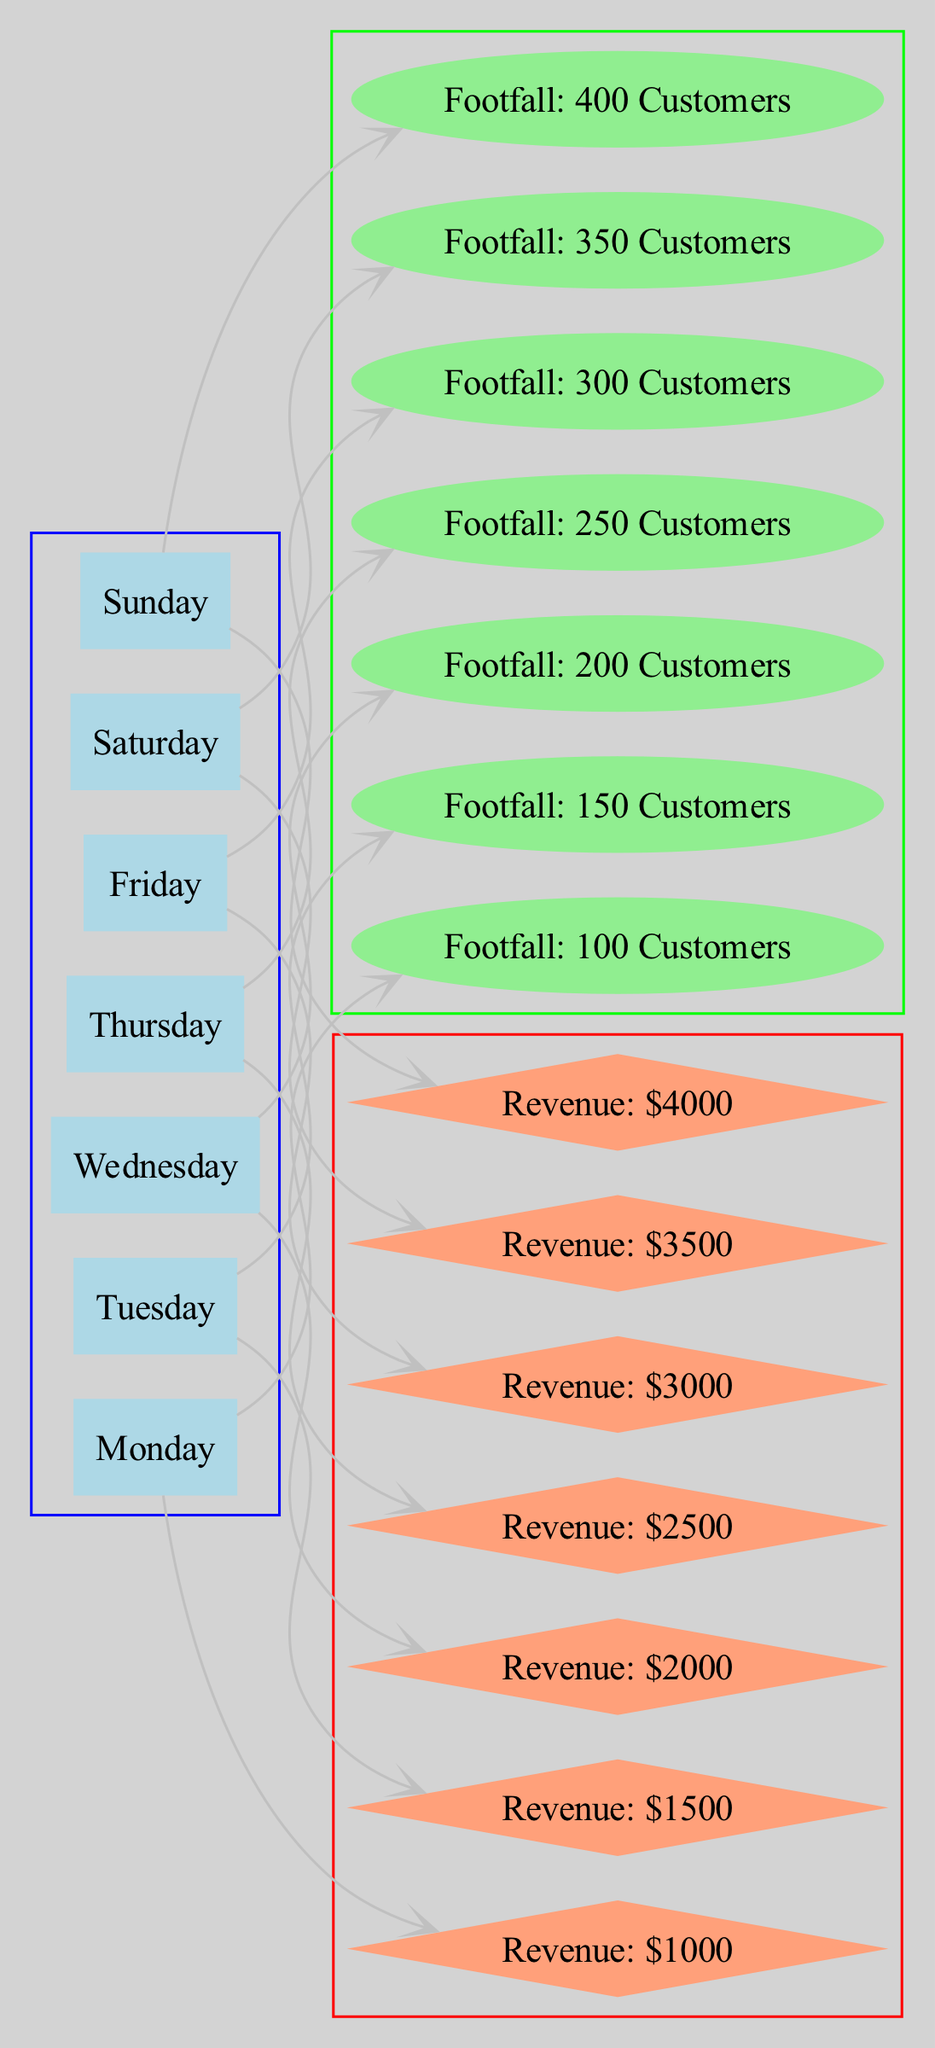What is the footfall on Wednesday? The diagram explicitly lists the footfall values associated with each day. For Wednesday, it states "Footfall: 200 Customers.”
Answer: 200 Customers What is the revenue for Friday? The revenue values are also clearly displayed in the diagram. For Friday, it indicates "Revenue: $3000.”
Answer: $3000 Which day has the highest customer footfall? By comparing the footfall values for each day, Sunday has the highest value listed as "Footfall: 400 Customers."
Answer: Sunday What is the relationship between Saturday and its revenue? The diagram connects Saturday to both footfall and revenue nodes. For Saturday, it states "Footfall: 350 Customers" and "Revenue: $3500." This shows that as footfall increases, revenue also rises.
Answer: Footfall: 350 Customers, Revenue: $3500 How many nodes represent days of the week in the diagram? The diagram contains seven nodes specifically for each day of the week, labeling them as Monday through Sunday.
Answer: 7 Which day shows a revenue value equal to its footfall value times ten? By analyzing the values, it can be inferred that the revenue for each day is ten times the footfall value. For instance, for Thursday, the footfall is "Footfall: 250 Customers," thus the revenue of "Revenue: $2500" is ten times that number.
Answer: Thursday How many edges connect to the Friday node? The diagram indicates that Friday has two connections: one for footfall and one for revenue, totaling two edges leading from Friday.
Answer: 2 What is the total revenue generated from all days of the week? By adding the individual revenue values listed for each day: $1000 (Mon) + $1500 (Tue) + $2000 (Wed) + $2500 (Thu) + $3000 (Fri) + $3500 (Sat) + $4000 (Sun), the total comes to $18500.
Answer: $18500 Which day has the least customer footfall? The diagram shows that Monday has the lowest footfall value, which is "Footfall: 100 Customers."
Answer: Monday 